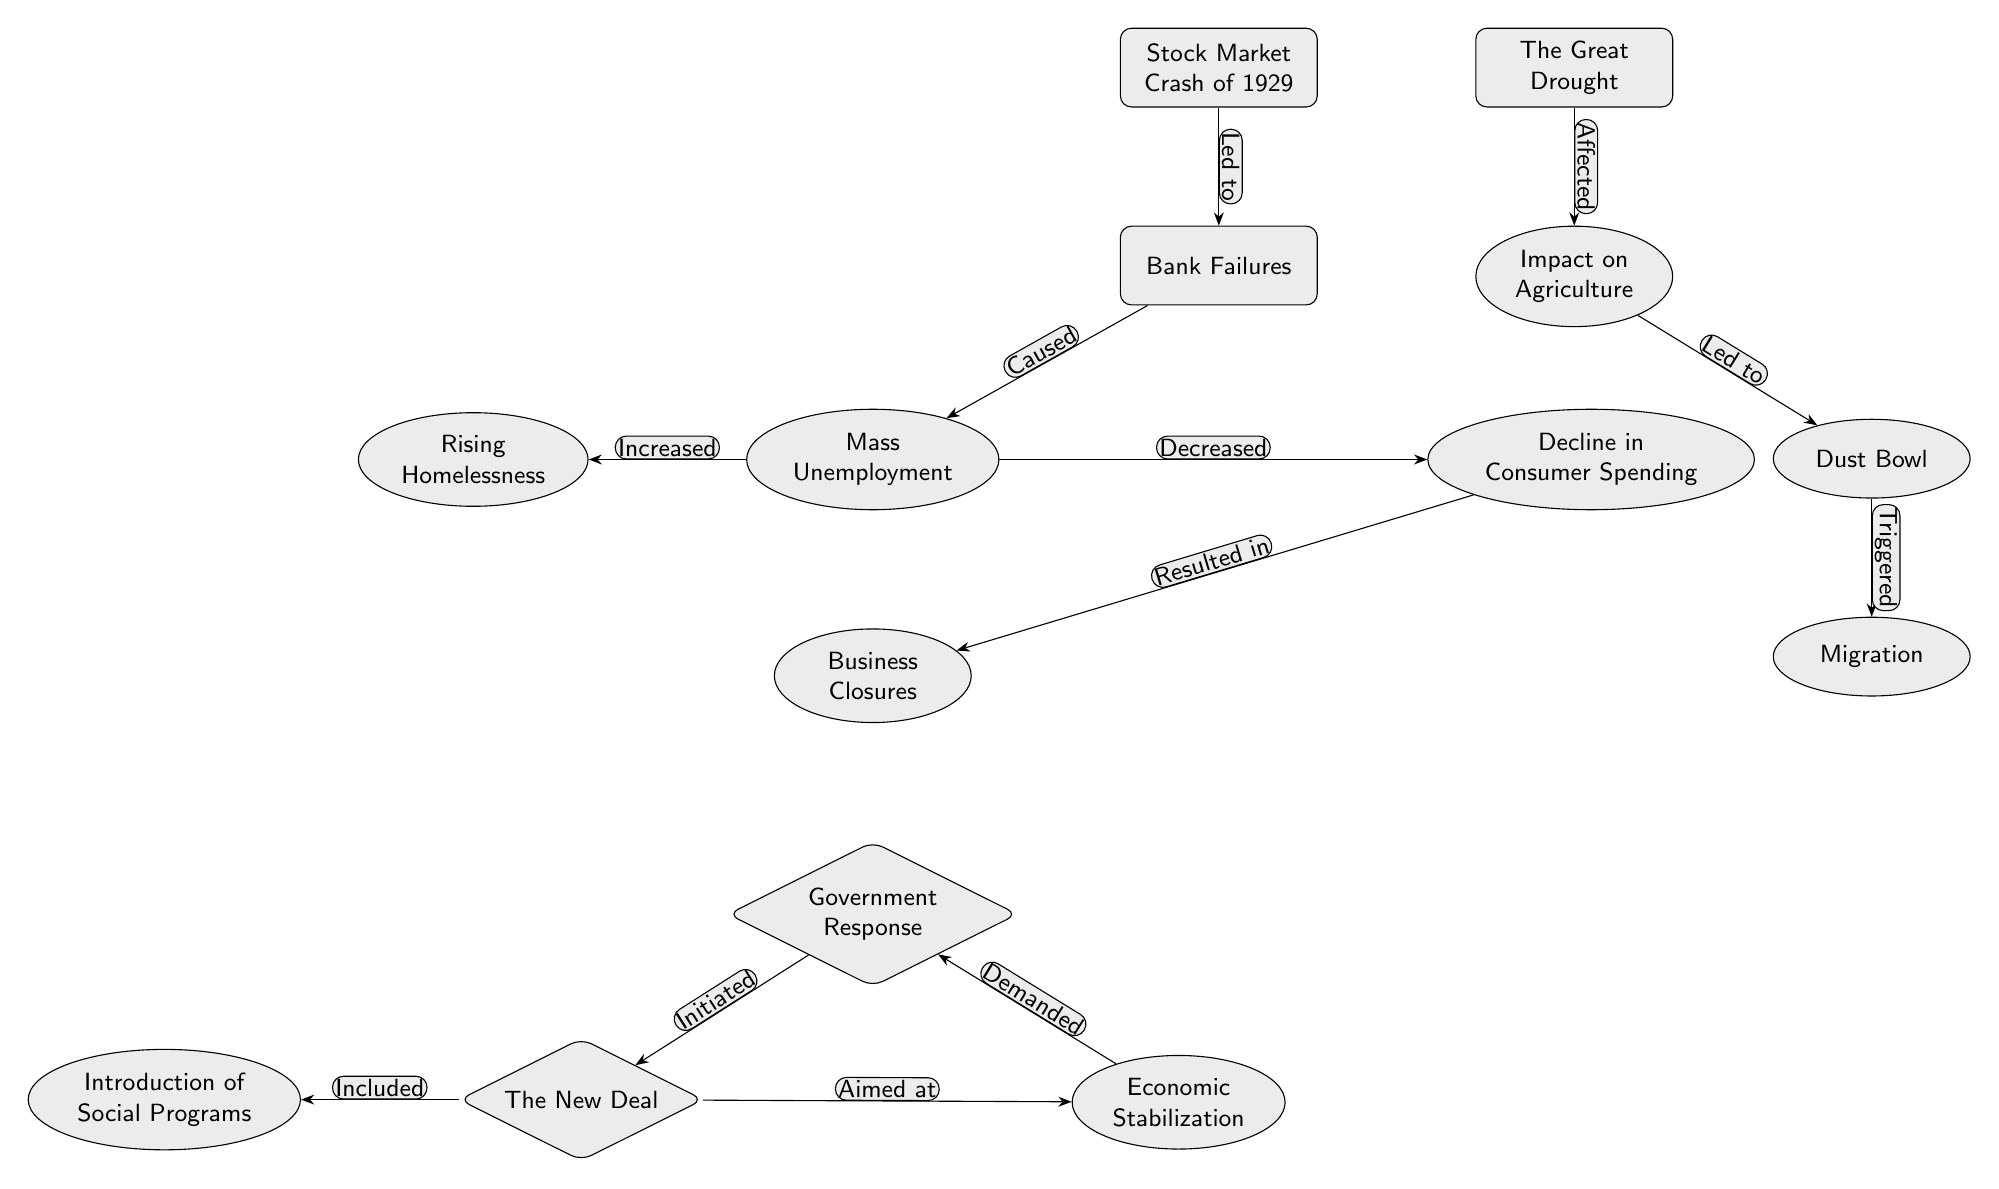What event triggered mass unemployment? The diagram indicates that "Bank Failures" directly follow "Stock Market Crash of 1929," which then leads to "Mass Unemployment." Hence, the "Stock Market Crash of 1929" is the event that triggered the unemployment.
Answer: Stock Market Crash of 1929 How many effects stem from "Bank Failures"? In the diagram, there are two distinct effects that stem from "Bank Failures": "Mass Unemployment" and "Decline in Consumer Spending." Therefore, we count two effects.
Answer: 2 Which response was initiated by the government? The diagram shows that the "Government Response" leads to "The New Deal." On examining the nodes, "The New Deal" is the specific response initiated by the government.
Answer: The New Deal What factor led to the Dust Bowl? The arrow pointing from "Impact on Agriculture" indicates that this factor led to the "Dust Bowl." It clearly outlines the progression from one node to the other.
Answer: Impact on Agriculture What does the diagram suggest about the relationship between "The New Deal" and "Economic Stabilization"? According to the diagram, "The New Deal" was aimed at achieving "Economic Stabilization." Thus, there is a direct causal relationship where the New Deal has the goal to stabilize the economy.
Answer: Aimed at What node represents the impact on individuals due to business closures? The impact on individuals due to business closures is represented by "Rising Homelessness," which has a direct flow from "Business Closures" in the diagram.
Answer: Rising Homelessness What major event influenced agriculture in the USA during the Great Depression? "The Great Drought" is shown to have affected agriculture in the diagram, clearly indicating its influence on that sector during the Great Depression.
Answer: The Great Drought Which effect is a response to mass unemployment? The diagram indicates that the "Government Response" is a reaction to "Mass Unemployment," as it is placed directly below and associated with it.
Answer: Government Response What social program introduction is mentioned in the diagram? The diagram notes "Introduction of Social Programs," which is a direct result of "The New Deal," highlighting the social impact of the policy during this period.
Answer: Introduction of Social Programs 